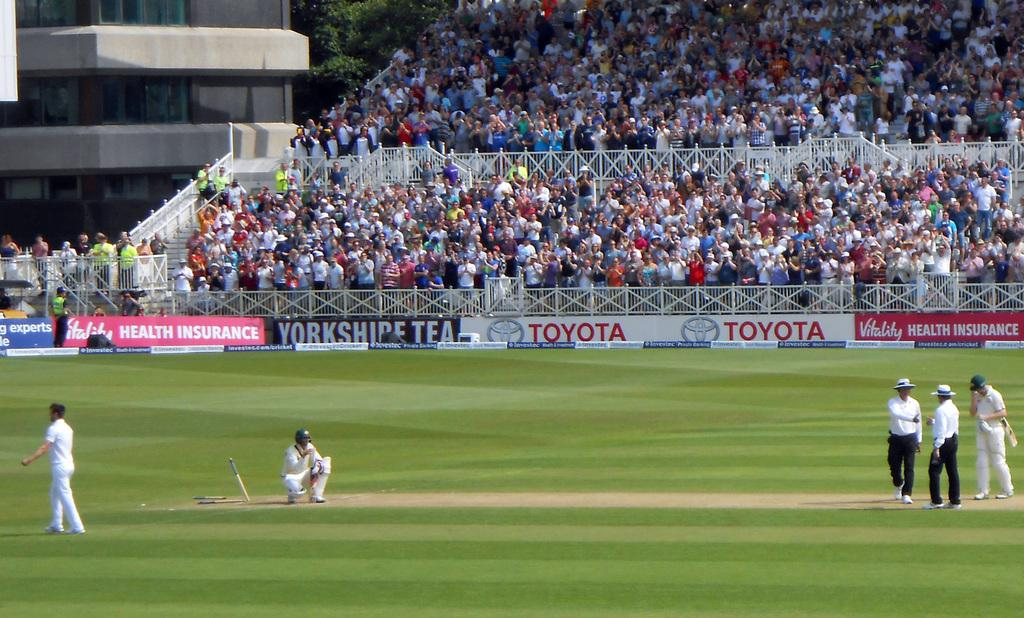What is happening on the ground in the image? There are people on the ground in the image. What can be seen on the sides of the image? There are hoardings in the image. What is present to provide safety or support in the image? There is railing in the image. What is the general atmosphere in the image? There is a crowd in the image. What can be seen in the distance in the image? There is a building and trees in the background of the image. Can you tell me how many crows are sitting on the railing in the image? There are no crows present in the image; only people, hoardings, railing, a crowd, a building, and trees can be seen. What subject is being taught in the image? There is no teaching activity depicted in the image. 